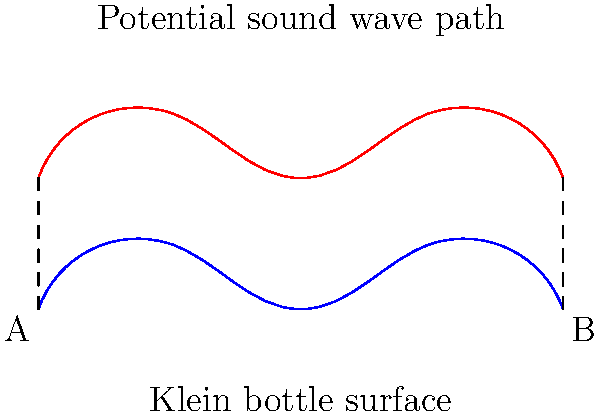Based on the Klein bottle representation shown, how might the non-Euclidean geometry of this surface influence the propagation of sound waves in a musical instrument inspired by this shape? Consider the potential path of a sound wave as indicated by the red curve. To understand how the Klein bottle geometry might influence sound propagation in a musical instrument, let's analyze the diagram step-by-step:

1. The blue curve represents the surface of a Klein bottle, which is a non-orientable surface without an inside or outside.

2. The red curve shows a potential path of a sound wave on this surface.

3. In a Klein bottle:
   a) The surface appears to pass through itself without actually intersecting.
   b) It has no boundary, meaning sound waves could theoretically travel continuously without reflection.

4. Sound wave behavior:
   a) As the wave travels along the red path, it would experience continuous changes in curvature.
   b) At point A, the wave would seem to split, with part continuing on the "outside" and part on the "inside."
   c) At point B, these separated parts would reconnect seamlessly.

5. Implications for a musical instrument:
   a) The continuous nature of the surface could lead to sustained tones with unique harmonic properties.
   b) The varying curvature along the path would likely cause frequency modulations as the wave travels.
   c) The apparent splitting and recombining of the wave at points A and B could create interesting interference patterns and phase shifts.

6. Potential instrument design:
   a) Could involve a tubular structure with specific points of sound input and output.
   b) Might use materials with varying elasticity to mimic the changing geometry of the Klein bottle.
   c) Could incorporate multiple sound sources to take advantage of the surface's unique properties.

7. Musical effects:
   a) Potentially produce tones with complex overtone structures due to the non-Euclidean geometry.
   b) Might create phasing effects as waves travel different "paths" and recombine.
   c) Could result in unexpected resonances and standing wave patterns.
Answer: Non-linear wave propagation with phase shifts and complex harmonics due to continuous, self-intersecting surface. 